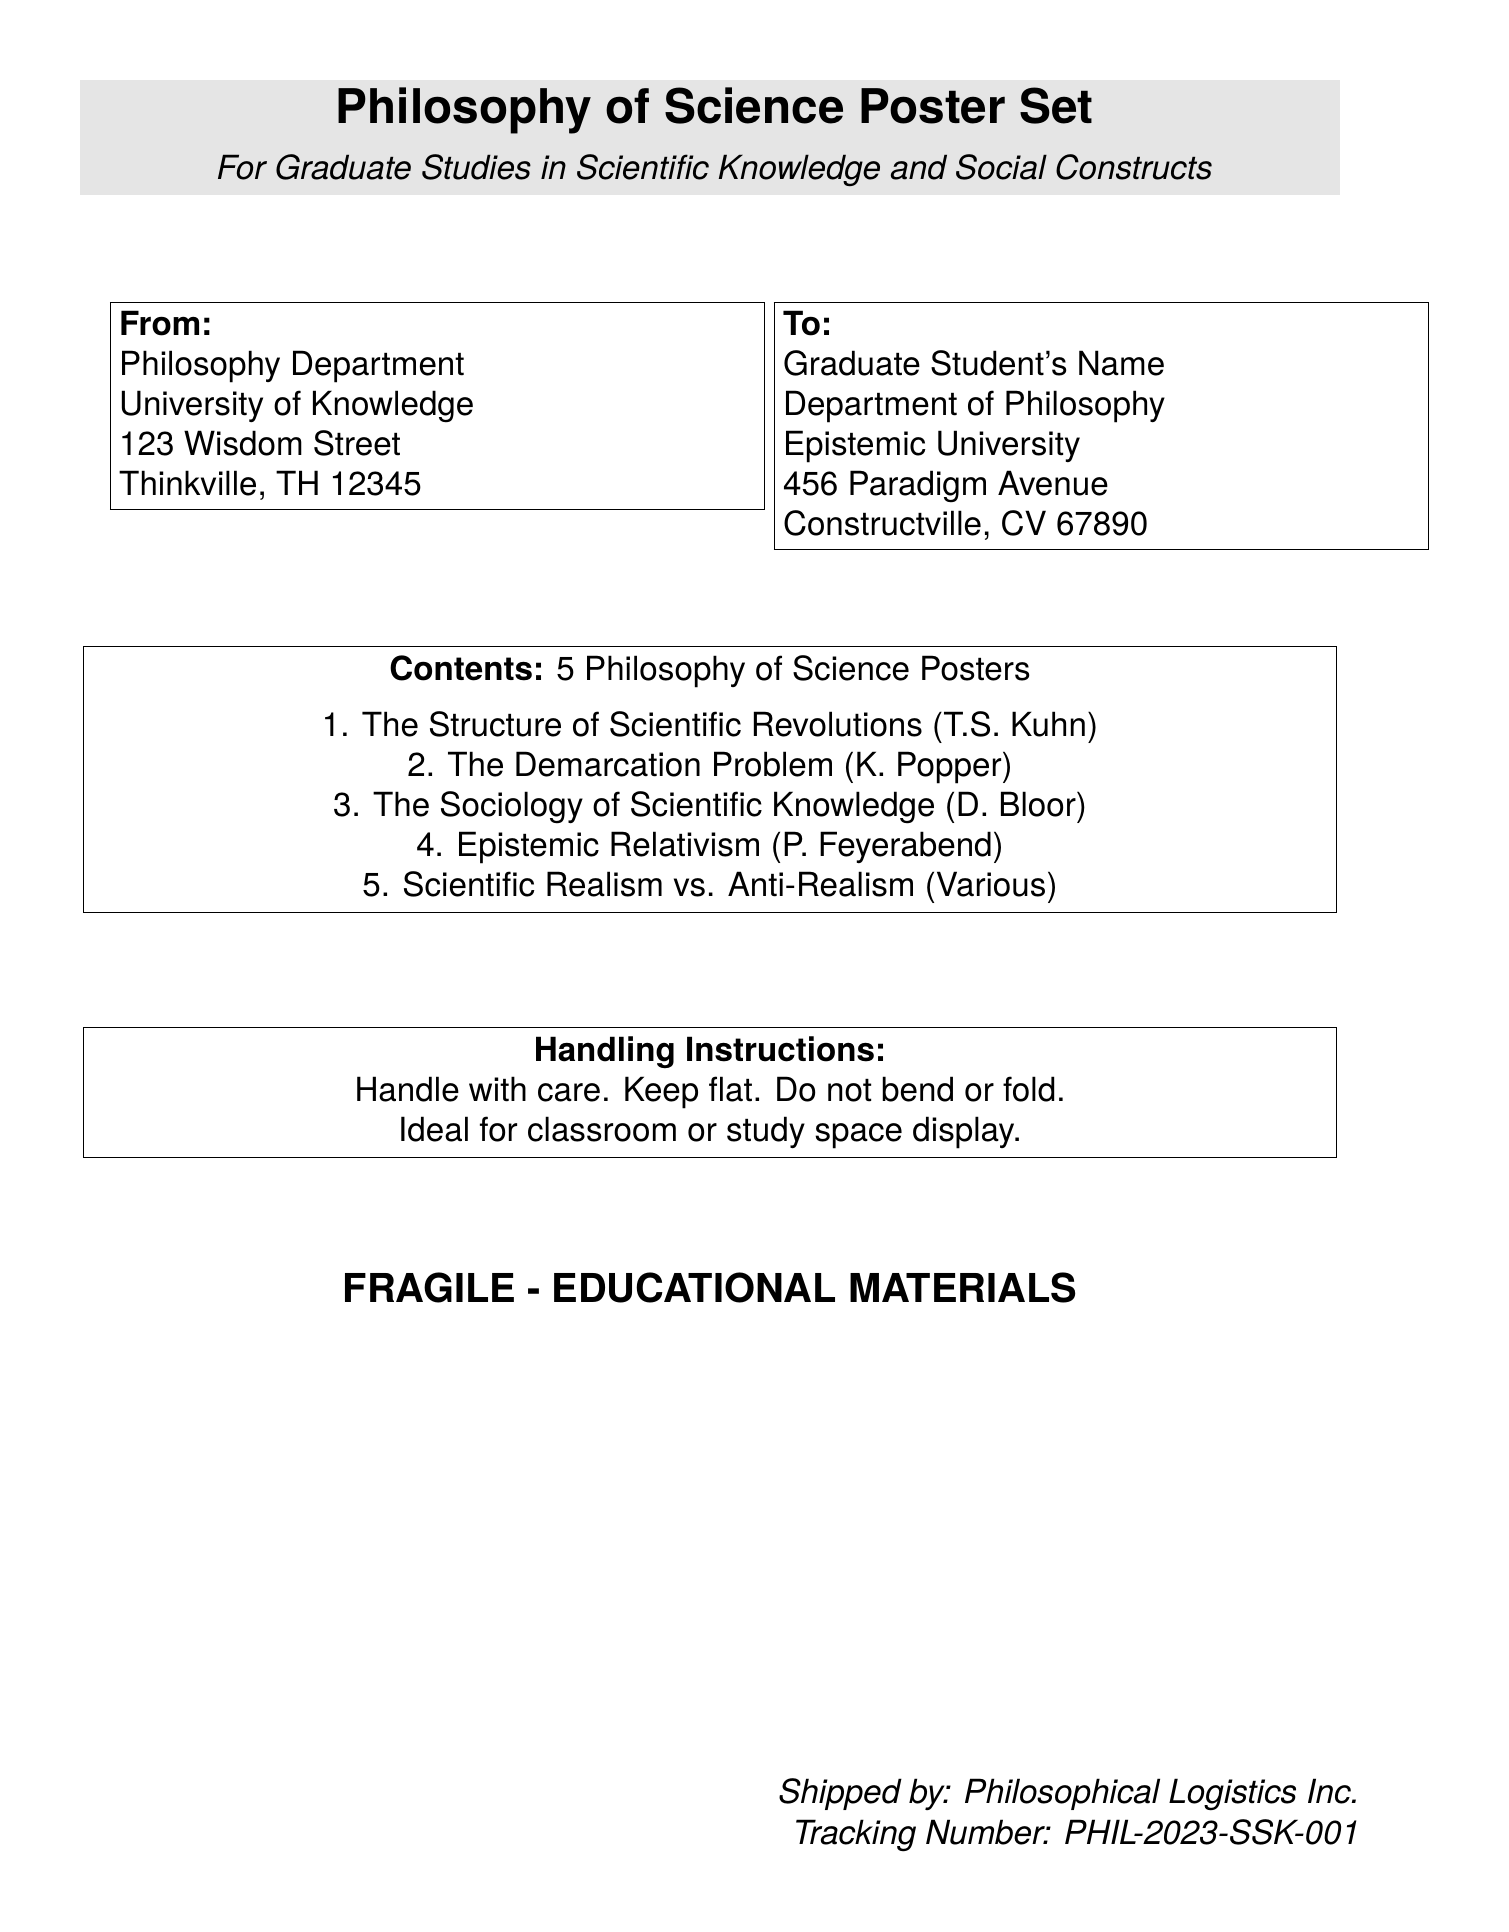What is the total number of posters? The document states that there are 5 posters included in the Philosophy of Science Poster Set.
Answer: 5 Who is the sender of the package? The document specifies that the package is sent from the Philosophy Department at the University of Knowledge.
Answer: Philosophy Department, University of Knowledge What is the tracking number? The tracking number is provided in the document as PHIL-2023-SSK-001.
Answer: PHIL-2023-SSK-001 What is the main theme of the posters? The posters are centered around theories in the philosophy of science, as indicated in the heading of the document.
Answer: Philosophy of Science What instruction is given regarding the handling of the package? It is noted in the document that the package should be handled with care and kept flat.
Answer: Handle with care. Keep flat 